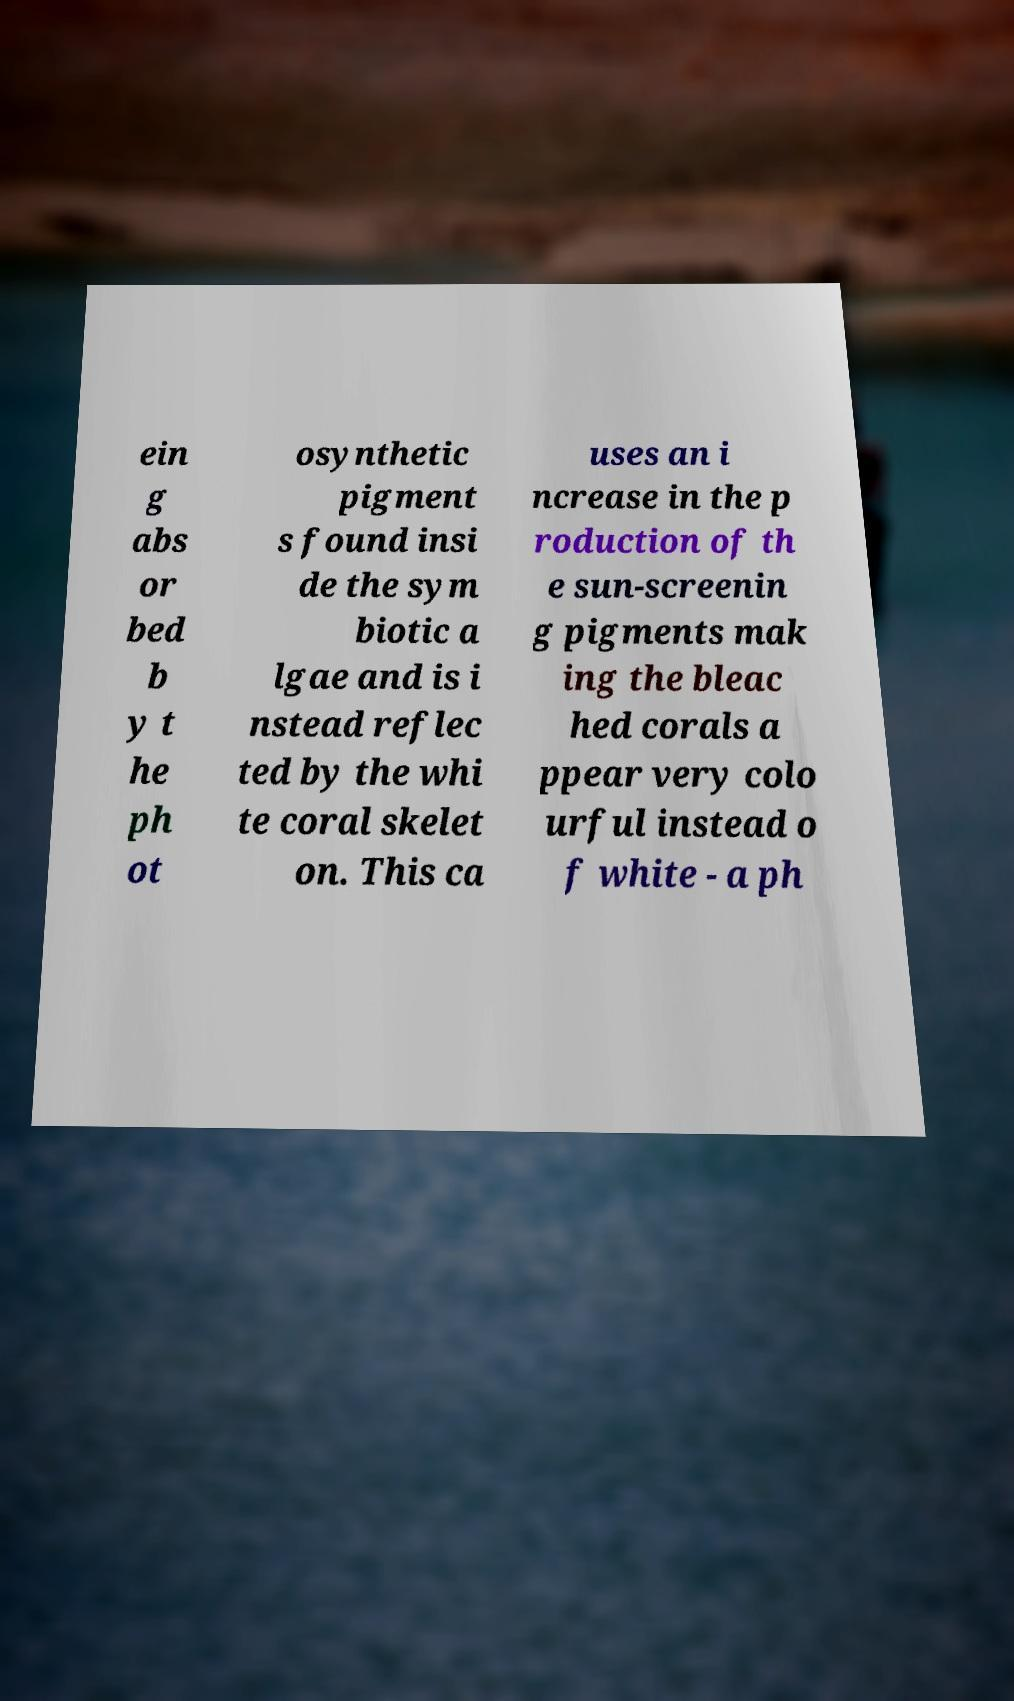Could you extract and type out the text from this image? ein g abs or bed b y t he ph ot osynthetic pigment s found insi de the sym biotic a lgae and is i nstead reflec ted by the whi te coral skelet on. This ca uses an i ncrease in the p roduction of th e sun-screenin g pigments mak ing the bleac hed corals a ppear very colo urful instead o f white - a ph 